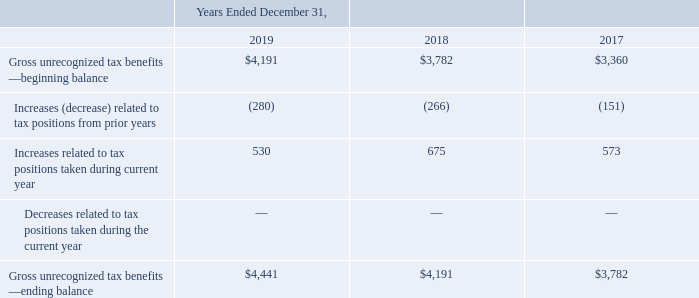Uncertain Tax Positions
As of December 31, 2019, 2018 and 2017, we had gross unrecognized tax benefits of $4.4 million, $4.2 million
and $3.8 million, respectively. Accrued interest expense related to unrecognized tax benefits is recognized as part of
our income tax provision in our consolidated statements of operations and is immaterial for the years ended
December 31, 2019 and 2018. Our policy for classifying interest and penalties associated with unrecognized income
tax benefits is to include such items in income tax expense.
The activity related to the unrecognized tax benefits is as follows (in thousands):
These amounts are related to certain deferred tax assets with a corresponding valuation allowance. As ofDecember 31, 2019, the total amount of unrecognized tax benefits, if recognized, that would affect the effective taxrate is $1.0 million. We do not anticipate a material change to our unrecognized tax benefits over the next twelvemonths. Unrecognized tax benefits may change during the next twelve months for items that arise in the ordinarycourse of business.
We are subject to taxation in the United States, various states, and several foreign jurisdictions. Because we havenet operating loss and credit carryforwards, there are open statutes of limitations in which federal, state and foreigntaxing authorities may examine our tax returns for all years from 2005 through the current period. We are notcurrently under examination by any taxing authorities.
What is the company's unrecognized tax benefit in 2019?
Answer scale should be: thousand. $4,441. What is the company's unrecognized tax benefit in 2018?
Answer scale should be: thousand. $4,191. What is the company's unrecognized tax benefit in 2017?
Answer scale should be: thousand. $3,782. What is the company's gross unrecognized tax benefits - ending balance in 2016?
Answer scale should be: thousand. $4,441 + $4,191 + $3,782 
Answer: 12414. What is the company's change in beginning balance between 2018 and 2019?
Answer scale should be: percent. ($4,191 - $3,782)/$3,782 
Answer: 10.81. What is the total increases related to tax positions taken during current year in 2018 and 2019?
Answer scale should be: thousand. 530 + 675 
Answer: 1205. 